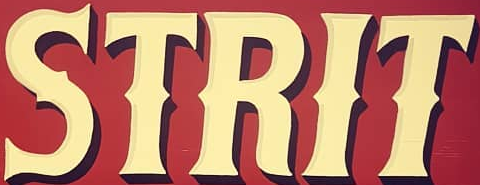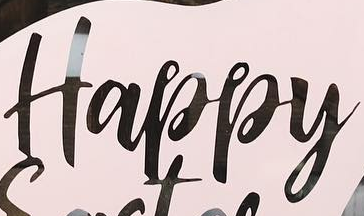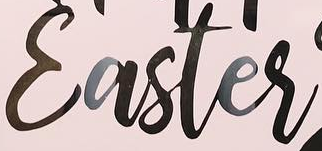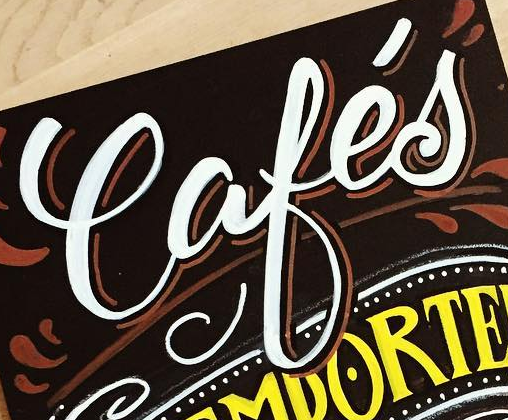What text is displayed in these images sequentially, separated by a semicolon? STRIT; Happy; Easter; Cafés 